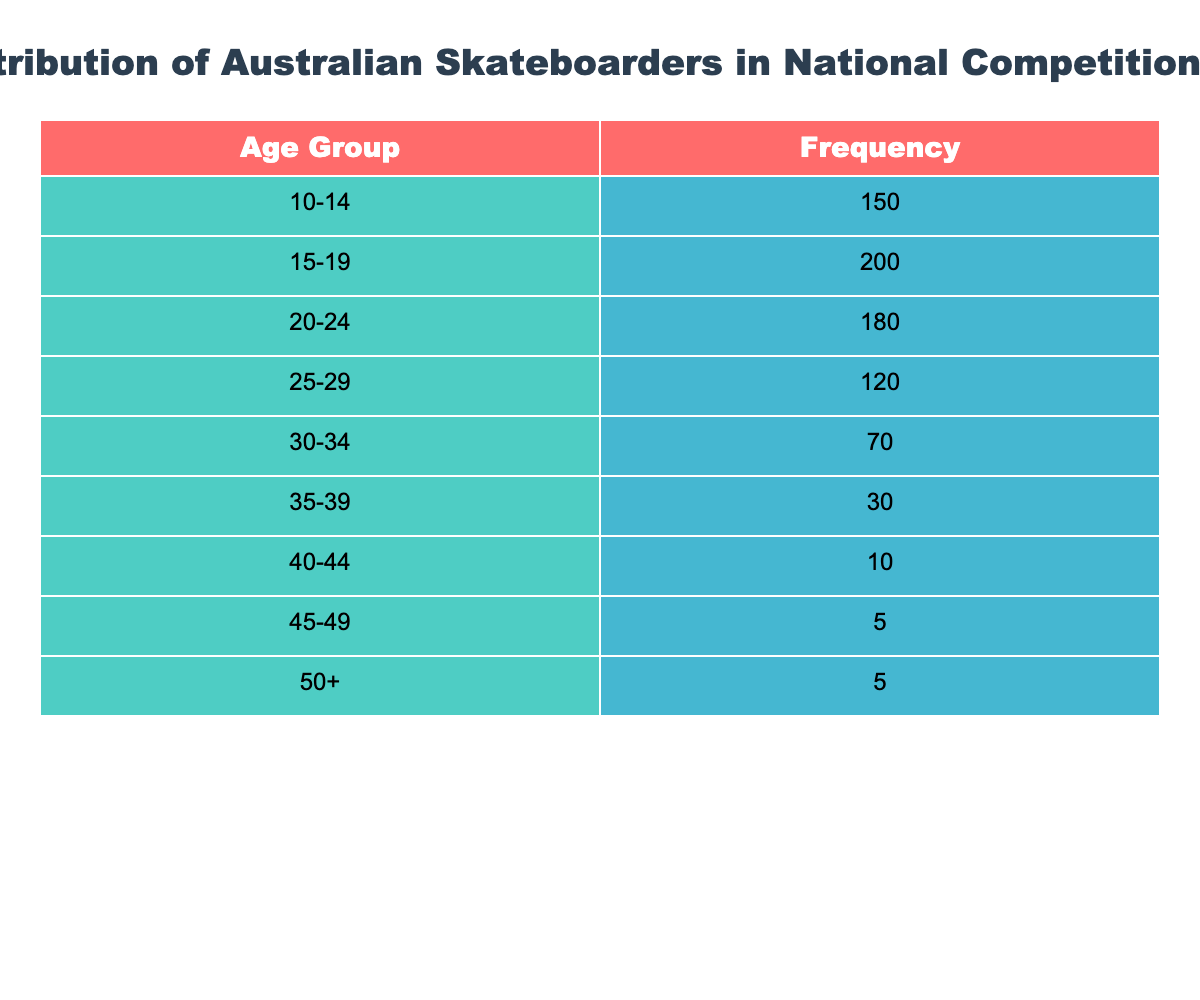What is the frequency of skateboarders aged 15-19? The table indicates that the frequency of skateboarders in the age group 15-19 is listed directly under the Frequency column. Specifically, it shows a value of 200.
Answer: 200 How many skateboarders are aged 30-34? The table specifies that the frequency of skateboarders within the age group 30-34 is 70, which can be found directly in the table under the corresponding rows.
Answer: 70 What is the total number of skateboarders across all age groups? To find the total, add the frequencies of all age groups: 150 + 200 + 180 + 120 + 70 + 30 + 10 + 5 + 5 = 770. Thus, the total frequency of skateboarders is 770.
Answer: 770 Is there any age group with a frequency greater than 150? By examining the table, the age groups 15-19 (200), 20-24 (180), and 10-14 (150) all contain frequencies that are equal to or greater than 150. Therefore, the answer is yes.
Answer: Yes What is the average age group size of skateboarders aged 25 and older? First, identify the frequency for age groups 25-29, 30-34, 35-39, 40-44, 45-49, and 50+. Their frequencies are 120, 70, 30, 10, 5, and 5, respectively. The sum of these values is 240, and there are 6 age groups. Thus, the average age group size is 240/6 = 40.
Answer: 40 How many more skateboarders are in the age group 15-19 than in the age group 40-44? The frequency for age group 15-19 is 200 and for 40-44 is 10. Therefore, the difference is 200 - 10 = 190. This indicates that there are 190 more skateboarders aged 15-19 than those aged 40-44.
Answer: 190 What percentage of skateboarders are aged 50 and older? The frequency of skateboarders aged 50+ is 5. To find the percentage, divide this by the total number (770) and multiply by 100: (5/770) * 100 ≈ 0.65%. Therefore, approximately 0.65% of skateboarders are aged 50 and older.
Answer: 0.65% Which age group has the least number of skateboarders? By reviewing the table, the age group with the lowest frequency is 45-49 with just 5 skateboarders. This is indicated directly in the table.
Answer: 45-49 What is the combined frequency of skateboarders aged 10-24? Combine the frequencies of age groups 10-14, 15-19, and 20-24, which are 150, 200, and 180 respectively. Summing these gives 150 + 200 + 180 = 530. So, the combined frequency is 530.
Answer: 530 